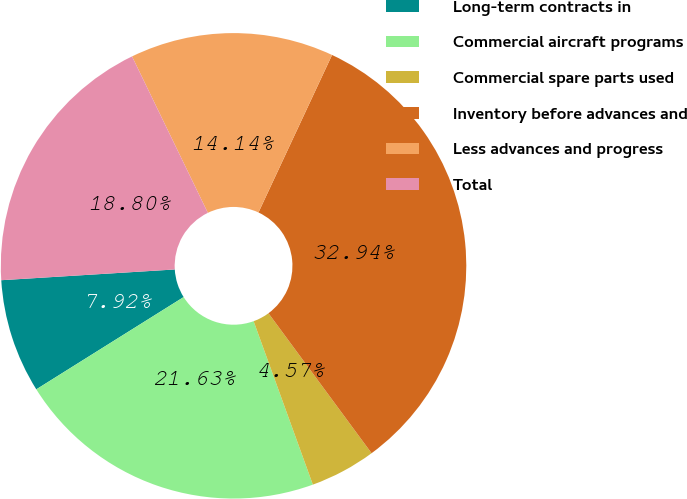Convert chart. <chart><loc_0><loc_0><loc_500><loc_500><pie_chart><fcel>Long-term contracts in<fcel>Commercial aircraft programs<fcel>Commercial spare parts used<fcel>Inventory before advances and<fcel>Less advances and progress<fcel>Total<nl><fcel>7.92%<fcel>21.63%<fcel>4.57%<fcel>32.94%<fcel>14.14%<fcel>18.8%<nl></chart> 